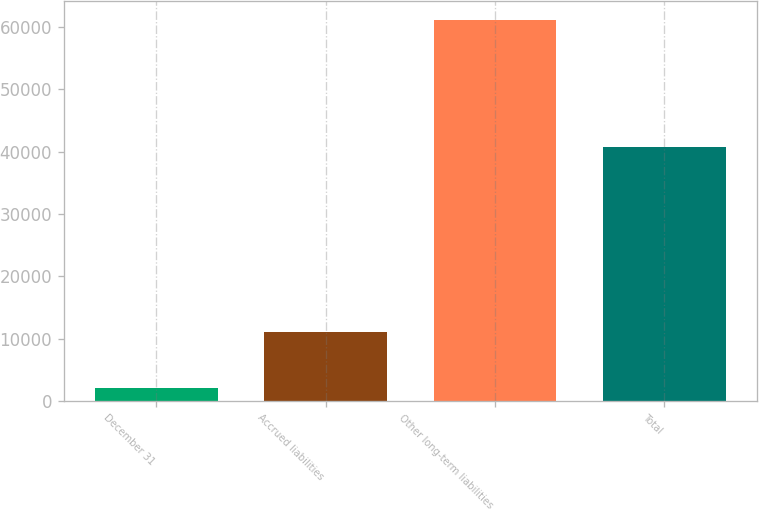Convert chart. <chart><loc_0><loc_0><loc_500><loc_500><bar_chart><fcel>December 31<fcel>Accrued liabilities<fcel>Other long-term liabilities<fcel>Total<nl><fcel>2008<fcel>11105<fcel>61194<fcel>40790<nl></chart> 